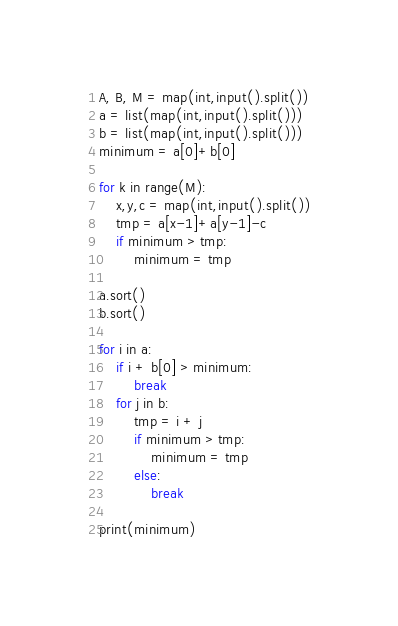<code> <loc_0><loc_0><loc_500><loc_500><_Python_>A, B, M = map(int,input().split())
a = list(map(int,input().split()))
b = list(map(int,input().split()))
minimum = a[0]+b[0]

for k in range(M):
    x,y,c = map(int,input().split())
    tmp = a[x-1]+a[y-1]-c
    if minimum > tmp:
        minimum = tmp

a.sort()
b.sort()

for i in a:
    if i + b[0] > minimum:
        break
    for j in b:
        tmp = i + j
        if minimum > tmp:
            minimum = tmp
        else:
            break

print(minimum)</code> 